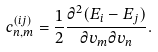Convert formula to latex. <formula><loc_0><loc_0><loc_500><loc_500>c _ { n , m } ^ { ( i j ) } = \frac { 1 } { 2 } \frac { \partial ^ { 2 } ( E _ { i } - E _ { j } ) } { \partial v _ { m } \partial v _ { n } } .</formula> 